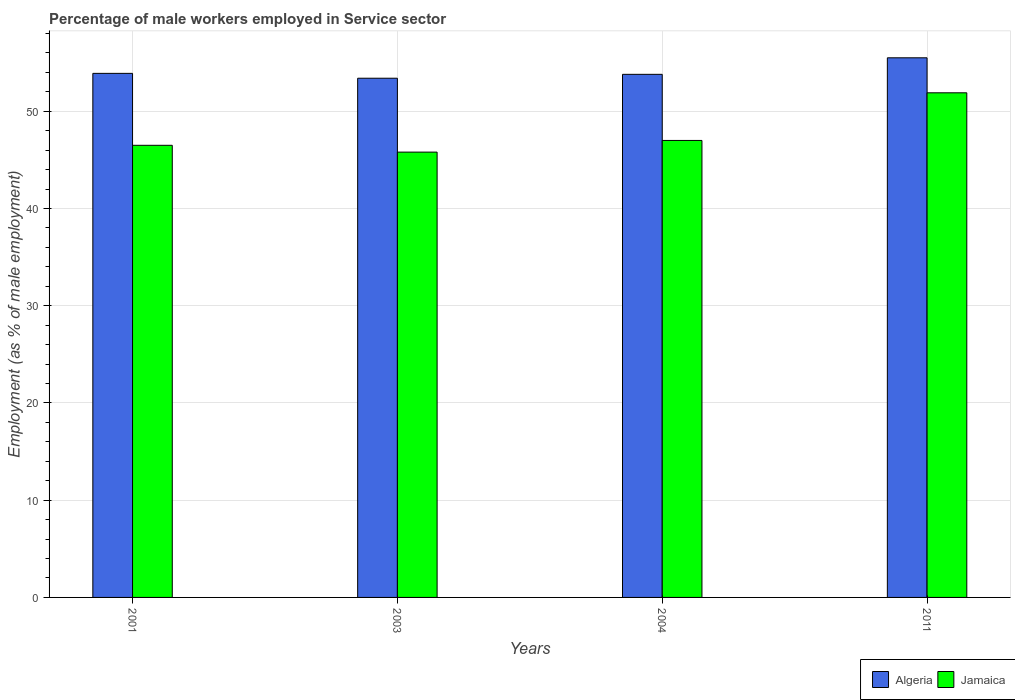Are the number of bars per tick equal to the number of legend labels?
Offer a very short reply. Yes. How many bars are there on the 1st tick from the left?
Provide a succinct answer. 2. How many bars are there on the 2nd tick from the right?
Your answer should be very brief. 2. What is the label of the 3rd group of bars from the left?
Provide a succinct answer. 2004. What is the percentage of male workers employed in Service sector in Jamaica in 2011?
Keep it short and to the point. 51.9. Across all years, what is the maximum percentage of male workers employed in Service sector in Algeria?
Your answer should be very brief. 55.5. Across all years, what is the minimum percentage of male workers employed in Service sector in Algeria?
Offer a terse response. 53.4. What is the total percentage of male workers employed in Service sector in Jamaica in the graph?
Provide a short and direct response. 191.2. What is the difference between the percentage of male workers employed in Service sector in Algeria in 2001 and that in 2011?
Give a very brief answer. -1.6. What is the difference between the percentage of male workers employed in Service sector in Algeria in 2001 and the percentage of male workers employed in Service sector in Jamaica in 2004?
Your answer should be very brief. 6.9. What is the average percentage of male workers employed in Service sector in Algeria per year?
Make the answer very short. 54.15. In the year 2011, what is the difference between the percentage of male workers employed in Service sector in Algeria and percentage of male workers employed in Service sector in Jamaica?
Your answer should be very brief. 3.6. What is the ratio of the percentage of male workers employed in Service sector in Algeria in 2003 to that in 2004?
Your response must be concise. 0.99. Is the percentage of male workers employed in Service sector in Algeria in 2001 less than that in 2003?
Make the answer very short. No. Is the difference between the percentage of male workers employed in Service sector in Algeria in 2001 and 2011 greater than the difference between the percentage of male workers employed in Service sector in Jamaica in 2001 and 2011?
Provide a short and direct response. Yes. What is the difference between the highest and the second highest percentage of male workers employed in Service sector in Jamaica?
Your answer should be compact. 4.9. What is the difference between the highest and the lowest percentage of male workers employed in Service sector in Jamaica?
Your answer should be compact. 6.1. What does the 2nd bar from the left in 2011 represents?
Your answer should be very brief. Jamaica. What does the 1st bar from the right in 2004 represents?
Give a very brief answer. Jamaica. How many bars are there?
Your answer should be compact. 8. Are all the bars in the graph horizontal?
Provide a short and direct response. No. Does the graph contain grids?
Ensure brevity in your answer.  Yes. What is the title of the graph?
Ensure brevity in your answer.  Percentage of male workers employed in Service sector. Does "Germany" appear as one of the legend labels in the graph?
Offer a very short reply. No. What is the label or title of the Y-axis?
Offer a terse response. Employment (as % of male employment). What is the Employment (as % of male employment) in Algeria in 2001?
Provide a succinct answer. 53.9. What is the Employment (as % of male employment) of Jamaica in 2001?
Offer a very short reply. 46.5. What is the Employment (as % of male employment) in Algeria in 2003?
Provide a short and direct response. 53.4. What is the Employment (as % of male employment) of Jamaica in 2003?
Make the answer very short. 45.8. What is the Employment (as % of male employment) in Algeria in 2004?
Offer a very short reply. 53.8. What is the Employment (as % of male employment) of Algeria in 2011?
Keep it short and to the point. 55.5. What is the Employment (as % of male employment) of Jamaica in 2011?
Keep it short and to the point. 51.9. Across all years, what is the maximum Employment (as % of male employment) in Algeria?
Offer a terse response. 55.5. Across all years, what is the maximum Employment (as % of male employment) in Jamaica?
Offer a terse response. 51.9. Across all years, what is the minimum Employment (as % of male employment) in Algeria?
Your answer should be compact. 53.4. Across all years, what is the minimum Employment (as % of male employment) of Jamaica?
Ensure brevity in your answer.  45.8. What is the total Employment (as % of male employment) in Algeria in the graph?
Give a very brief answer. 216.6. What is the total Employment (as % of male employment) of Jamaica in the graph?
Provide a short and direct response. 191.2. What is the difference between the Employment (as % of male employment) of Jamaica in 2001 and that in 2003?
Give a very brief answer. 0.7. What is the difference between the Employment (as % of male employment) of Jamaica in 2001 and that in 2011?
Provide a short and direct response. -5.4. What is the difference between the Employment (as % of male employment) in Algeria in 2003 and that in 2004?
Provide a succinct answer. -0.4. What is the difference between the Employment (as % of male employment) in Jamaica in 2003 and that in 2004?
Keep it short and to the point. -1.2. What is the difference between the Employment (as % of male employment) in Algeria in 2003 and that in 2011?
Give a very brief answer. -2.1. What is the difference between the Employment (as % of male employment) of Jamaica in 2003 and that in 2011?
Offer a very short reply. -6.1. What is the difference between the Employment (as % of male employment) of Algeria in 2004 and that in 2011?
Provide a short and direct response. -1.7. What is the difference between the Employment (as % of male employment) of Jamaica in 2004 and that in 2011?
Ensure brevity in your answer.  -4.9. What is the difference between the Employment (as % of male employment) in Algeria in 2001 and the Employment (as % of male employment) in Jamaica in 2003?
Offer a very short reply. 8.1. What is the difference between the Employment (as % of male employment) of Algeria in 2001 and the Employment (as % of male employment) of Jamaica in 2004?
Keep it short and to the point. 6.9. What is the difference between the Employment (as % of male employment) of Algeria in 2001 and the Employment (as % of male employment) of Jamaica in 2011?
Give a very brief answer. 2. What is the average Employment (as % of male employment) of Algeria per year?
Your answer should be very brief. 54.15. What is the average Employment (as % of male employment) in Jamaica per year?
Your answer should be very brief. 47.8. In the year 2001, what is the difference between the Employment (as % of male employment) in Algeria and Employment (as % of male employment) in Jamaica?
Offer a terse response. 7.4. What is the ratio of the Employment (as % of male employment) in Algeria in 2001 to that in 2003?
Your answer should be very brief. 1.01. What is the ratio of the Employment (as % of male employment) in Jamaica in 2001 to that in 2003?
Provide a succinct answer. 1.02. What is the ratio of the Employment (as % of male employment) of Algeria in 2001 to that in 2011?
Your response must be concise. 0.97. What is the ratio of the Employment (as % of male employment) of Jamaica in 2001 to that in 2011?
Keep it short and to the point. 0.9. What is the ratio of the Employment (as % of male employment) in Jamaica in 2003 to that in 2004?
Ensure brevity in your answer.  0.97. What is the ratio of the Employment (as % of male employment) of Algeria in 2003 to that in 2011?
Offer a terse response. 0.96. What is the ratio of the Employment (as % of male employment) of Jamaica in 2003 to that in 2011?
Provide a short and direct response. 0.88. What is the ratio of the Employment (as % of male employment) in Algeria in 2004 to that in 2011?
Your answer should be very brief. 0.97. What is the ratio of the Employment (as % of male employment) of Jamaica in 2004 to that in 2011?
Offer a terse response. 0.91. What is the difference between the highest and the second highest Employment (as % of male employment) in Algeria?
Your response must be concise. 1.6. What is the difference between the highest and the lowest Employment (as % of male employment) in Algeria?
Keep it short and to the point. 2.1. What is the difference between the highest and the lowest Employment (as % of male employment) of Jamaica?
Keep it short and to the point. 6.1. 